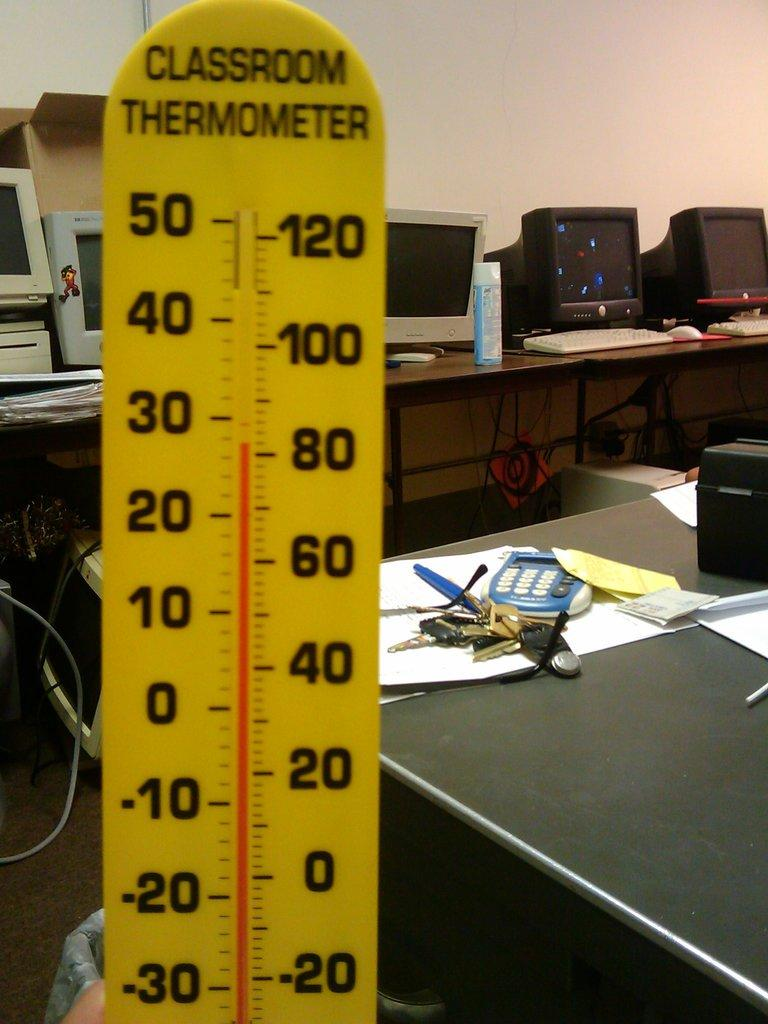<image>
Summarize the visual content of the image. A CLASSROOM THERMOMETER SHOWS IT IS OVER EIGHTY DEGREES 